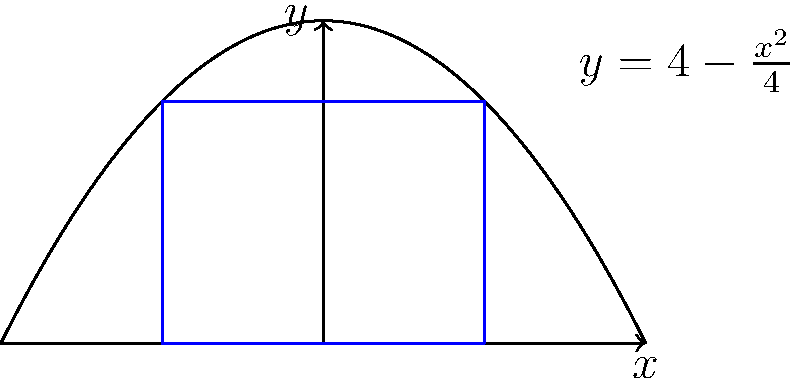A rectangle is inscribed in the parabola $y = 4 - \frac{x^2}{4}$ with its base on the x-axis, as shown in the figure. Find the dimensions of the rectangle that maximize its area. Let's approach this step-by-step:

1) Let the width of the rectangle be $2x$ and its height be $y$.

2) The area of the rectangle is $A = 2xy$.

3) Since the top of the rectangle lies on the parabola, we can express $y$ in terms of $x$:

   $y = 4 - \frac{x^2}{4}$

4) Now we can express the area solely in terms of $x$:

   $A = 2x(4 - \frac{x^2}{4}) = 8x - \frac{x^3}{2}$

5) To find the maximum area, we differentiate $A$ with respect to $x$ and set it to zero:

   $\frac{dA}{dx} = 8 - \frac{3x^2}{2} = 0$

6) Solving this equation:

   $8 - \frac{3x^2}{2} = 0$
   $\frac{3x^2}{2} = 8$
   $x^2 = \frac{16}{3}$
   $x = \pm \frac{4}{\sqrt{3}}$

7) Since we're dealing with width, we take the positive value: $x = \frac{4}{\sqrt{3}}$

8) The width of the rectangle is $2x = \frac{8}{\sqrt{3}}$

9) To find the height, we substitute this $x$ value into the equation of the parabola:

   $y = 4 - \frac{(\frac{4}{\sqrt{3}})^2}{4} = 4 - \frac{16}{12} = \frac{8}{3}$

Therefore, the dimensions that maximize the area are:
Width = $\frac{8}{\sqrt{3}}$, Height = $\frac{8}{3}$
Answer: Width = $\frac{8}{\sqrt{3}}$, Height = $\frac{8}{3}$ 